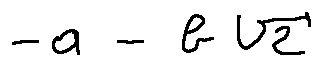<formula> <loc_0><loc_0><loc_500><loc_500>- a - b \sqrt { 2 }</formula> 